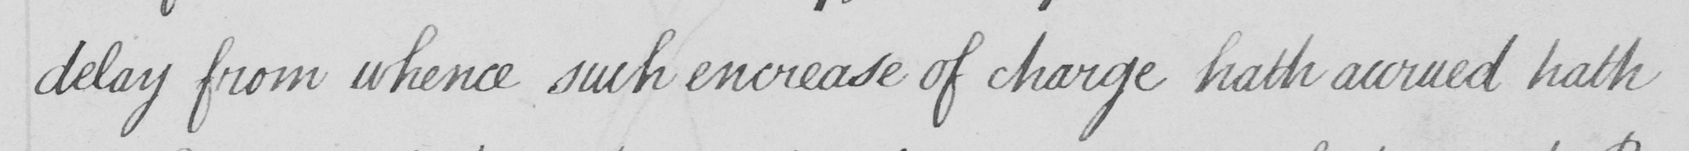Can you read and transcribe this handwriting? delay from whence such encrease of charge hath accrued hath 